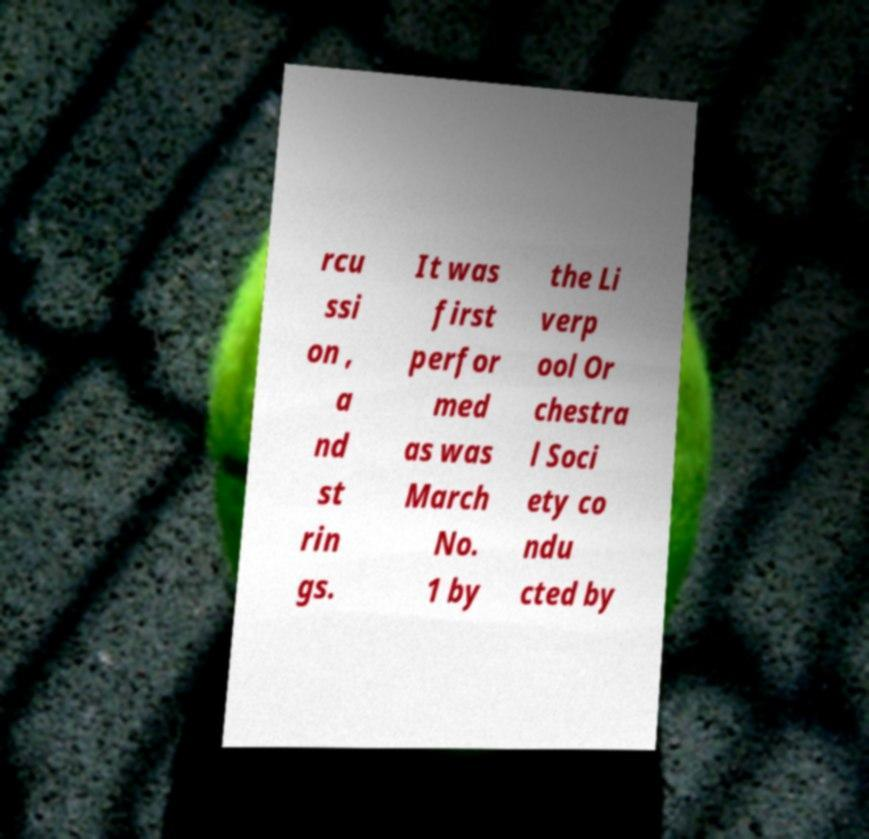What messages or text are displayed in this image? I need them in a readable, typed format. rcu ssi on , a nd st rin gs. It was first perfor med as was March No. 1 by the Li verp ool Or chestra l Soci ety co ndu cted by 